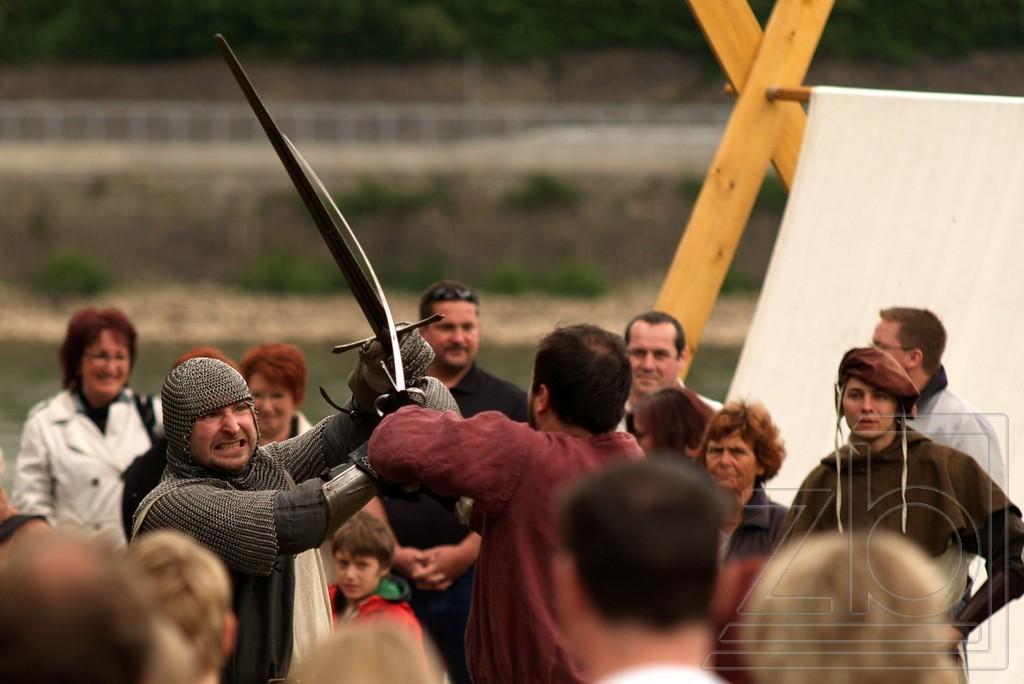Can you describe this image briefly? Here in this picture we can see two persons practicing fight with the help of swords in their hands and the person on the left side is wearing whole body Armour and around them we can see people standing and watching them and behind them we can see a cloth present there. 